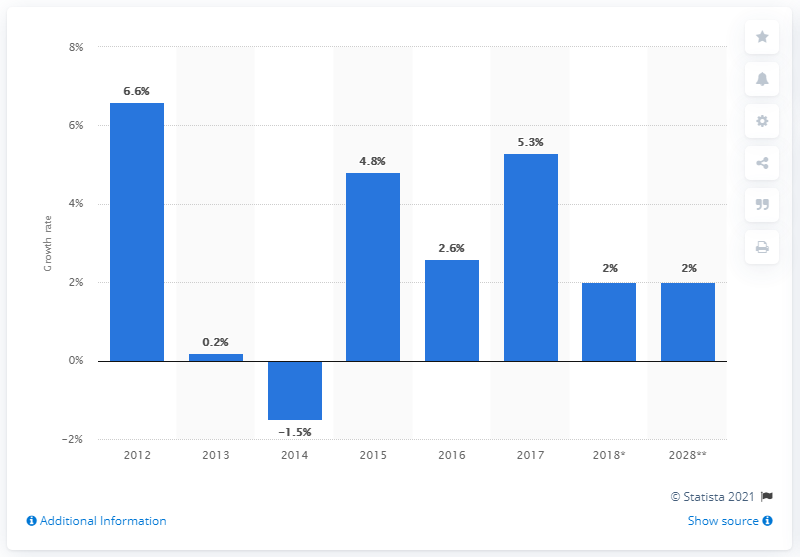Outline some significant characteristics in this image. In 2017, the travel and tourism industry experienced a growth rate of 5.3%. 